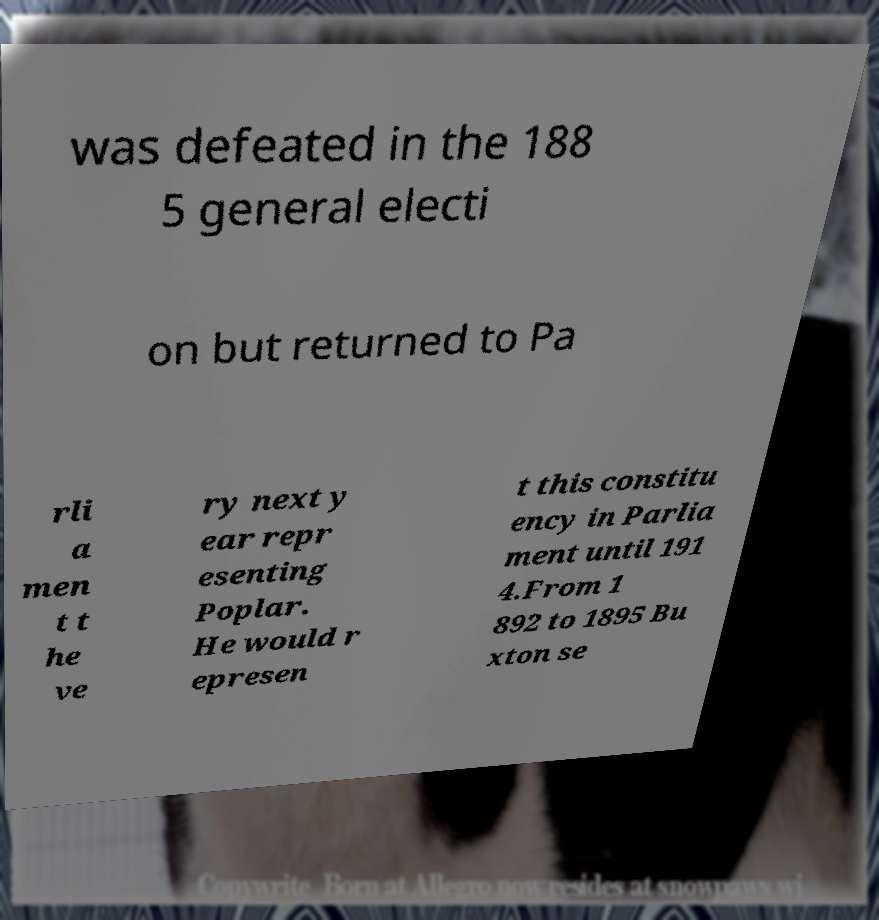Please read and relay the text visible in this image. What does it say? was defeated in the 188 5 general electi on but returned to Pa rli a men t t he ve ry next y ear repr esenting Poplar. He would r epresen t this constitu ency in Parlia ment until 191 4.From 1 892 to 1895 Bu xton se 